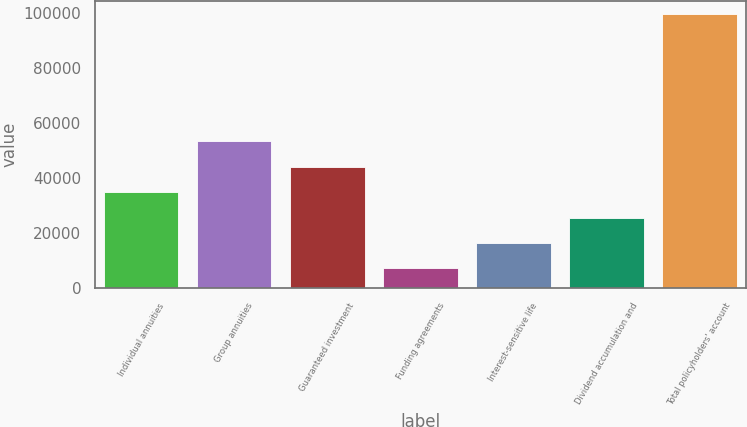Convert chart. <chart><loc_0><loc_0><loc_500><loc_500><bar_chart><fcel>Individual annuities<fcel>Group annuities<fcel>Guaranteed investment<fcel>Funding agreements<fcel>Interest-sensitive life<fcel>Dividend accumulation and<fcel>Total policyholders' account<nl><fcel>34987.6<fcel>53452<fcel>44219.8<fcel>7291<fcel>16523.2<fcel>25755.4<fcel>99613<nl></chart> 